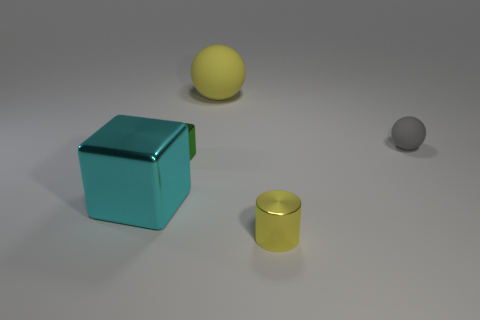Add 3 yellow metallic things. How many objects exist? 8 Subtract all spheres. How many objects are left? 3 Add 5 big matte spheres. How many big matte spheres are left? 6 Add 5 brown cylinders. How many brown cylinders exist? 5 Subtract 1 cyan cubes. How many objects are left? 4 Subtract all small red cylinders. Subtract all cyan metal objects. How many objects are left? 4 